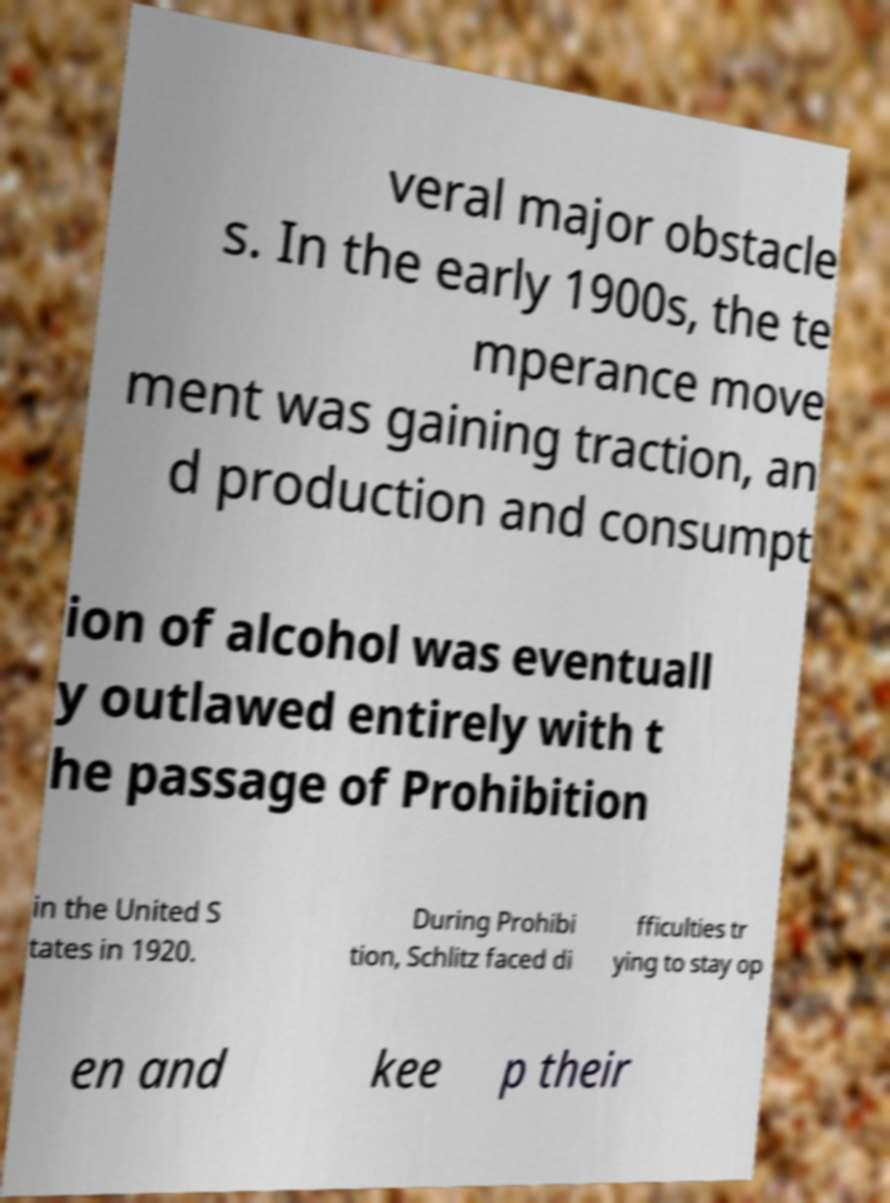Please identify and transcribe the text found in this image. veral major obstacle s. In the early 1900s, the te mperance move ment was gaining traction, an d production and consumpt ion of alcohol was eventuall y outlawed entirely with t he passage of Prohibition in the United S tates in 1920. During Prohibi tion, Schlitz faced di fficulties tr ying to stay op en and kee p their 